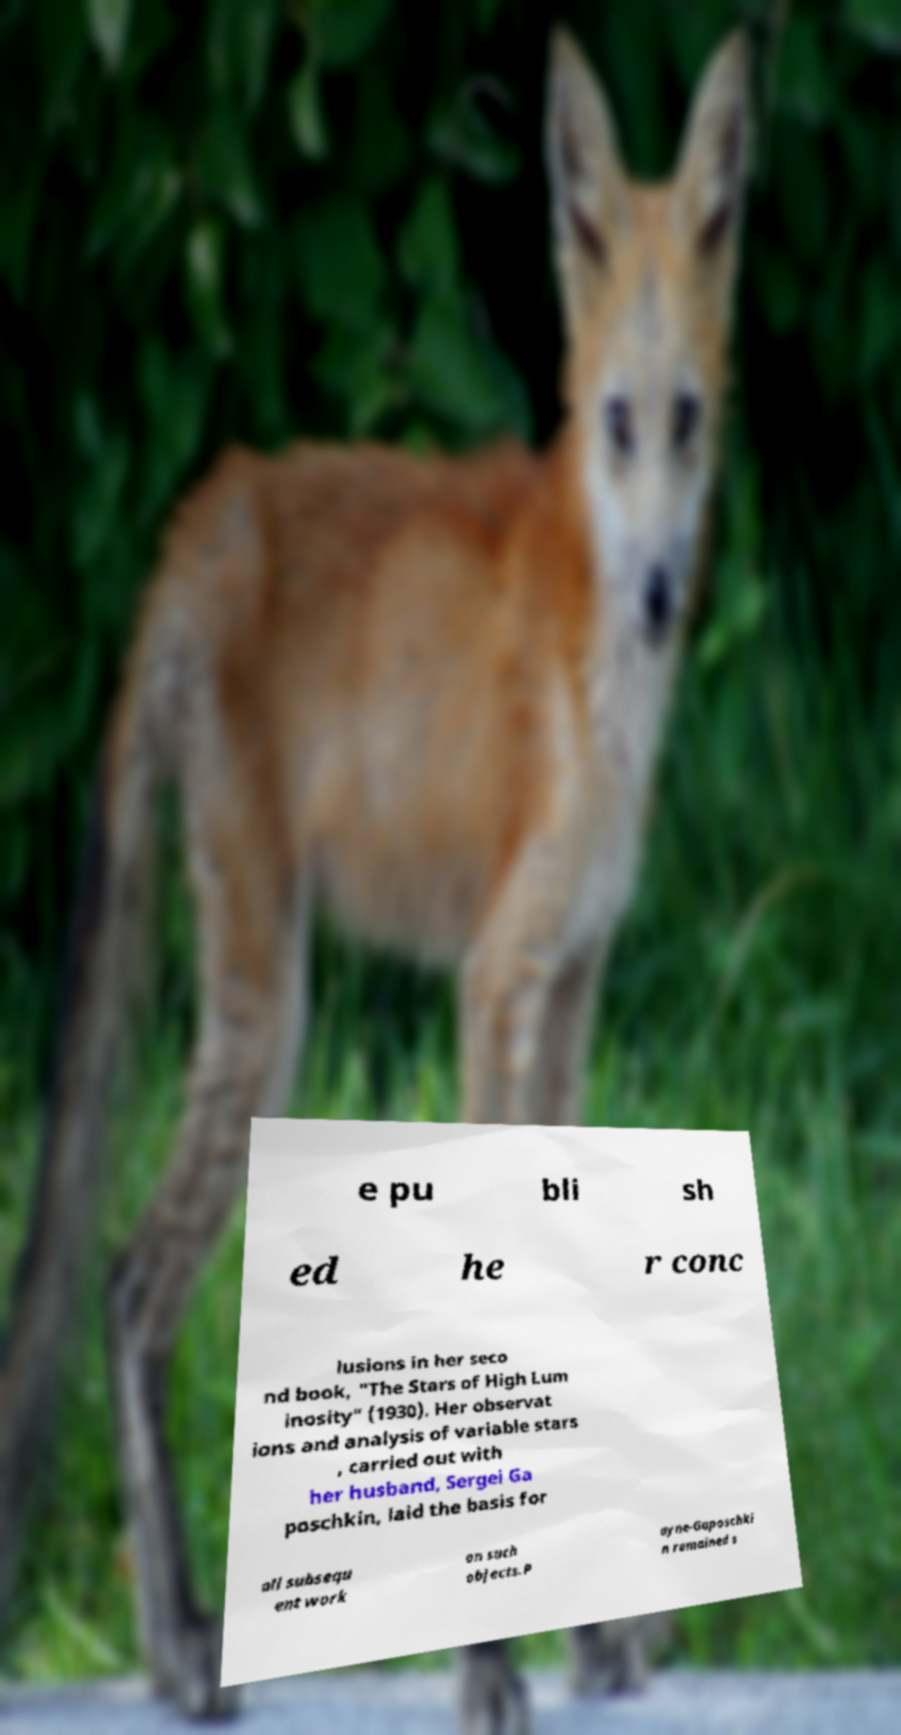Can you read and provide the text displayed in the image?This photo seems to have some interesting text. Can you extract and type it out for me? e pu bli sh ed he r conc lusions in her seco nd book, "The Stars of High Lum inosity" (1930). Her observat ions and analysis of variable stars , carried out with her husband, Sergei Ga poschkin, laid the basis for all subsequ ent work on such objects.P ayne-Gaposchki n remained s 